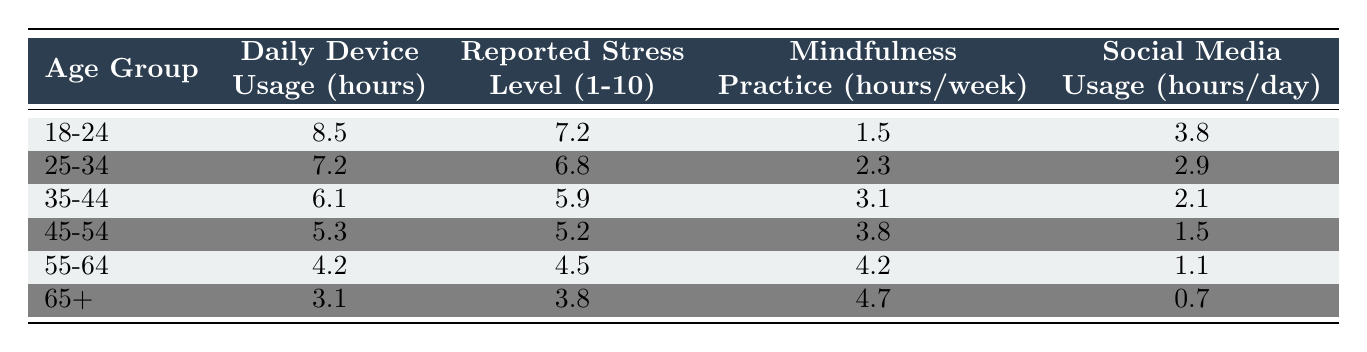What is the reported stress level for the age group 25-34? The reported stress level column shows that for the age group 25-34, the value is 6.8.
Answer: 6.8 Which age group has the highest daily device usage? The daily device usage column indicates that the age group 18-24 has the highest value of 8.5 hours.
Answer: 18-24 What is the mindfulness practice hours for the age group 55-64? The mindfulness practice hours column indicates that for the age group 55-64, the value is 4.2 hours per week.
Answer: 4.2 Is it true that social media usage decreases with age? By comparing the social media usage values across the age groups, we see that they decrease from 3.8 hours for 18-24 to 0.7 hours for 65+, supporting the idea that social media usage decreases with age.
Answer: Yes What is the average daily device usage across all age groups? The average is calculated by adding all the daily device usage values (8.5 + 7.2 + 6.1 + 5.3 + 4.2 + 3.1 = 34.4) and dividing by the number of age groups (6), which gives 34.4 / 6 = 5.73 hours.
Answer: 5.73 What is the difference in reported stress levels between the age groups 18-24 and 45-54? The reported stress level for 18-24 is 7.2 and for 45-54 is 5.2. The difference is 7.2 - 5.2 = 2.0.
Answer: 2.0 How many hours of mindfulness practice do individuals in the 35-44 age group engage in? The mindfulness practice column shows that individuals in the 35-44 age group engage in 3.1 hours per week.
Answer: 3.1 Which age group has the lowest daily device usage, and what is that usage? The age group 65+ has the lowest daily device usage at 3.1 hours.
Answer: 65+, 3.1 What is the combined reported stress level for the age groups 45-54 and 55-64? The reported stress level for 45-54 is 5.2 and for 55-64 is 4.5. Adding these gives 5.2 + 4.5 = 9.7.
Answer: 9.7 Does daily device usage correlate positively with reported stress levels based on the table? Observing the data, as daily device usage decreases, reported stress levels also tend to decrease, suggesting a negative correlation.
Answer: No 